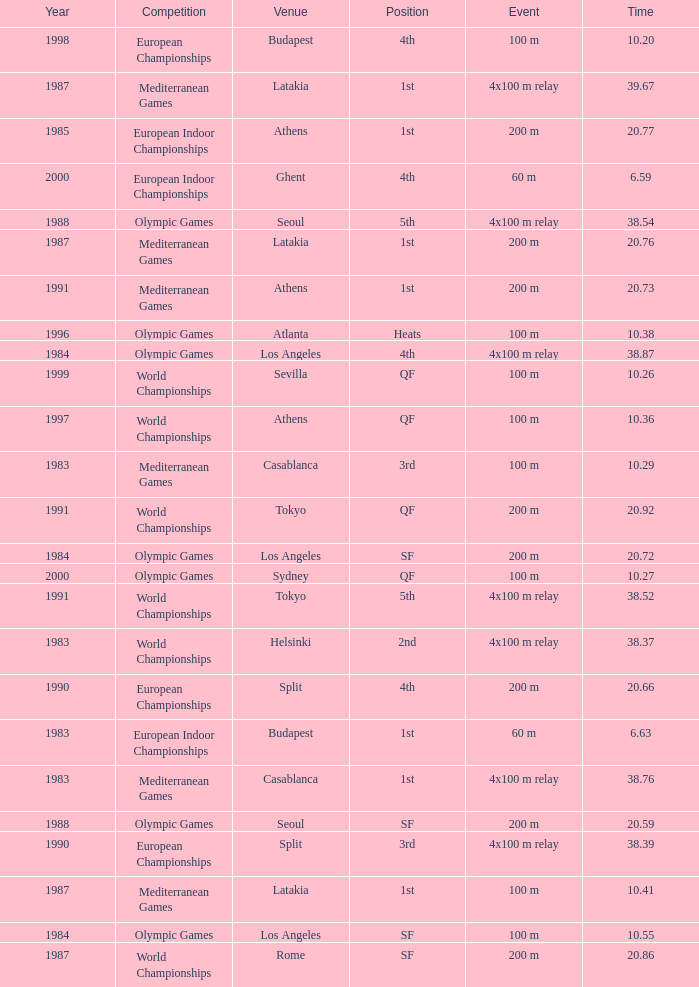What Event has a Position of 1st, a Year of 1983, and a Venue of budapest? 60 m. Could you help me parse every detail presented in this table? {'header': ['Year', 'Competition', 'Venue', 'Position', 'Event', 'Time'], 'rows': [['1998', 'European Championships', 'Budapest', '4th', '100 m', '10.20'], ['1987', 'Mediterranean Games', 'Latakia', '1st', '4x100 m relay', '39.67'], ['1985', 'European Indoor Championships', 'Athens', '1st', '200 m', '20.77'], ['2000', 'European Indoor Championships', 'Ghent', '4th', '60 m', '6.59'], ['1988', 'Olympic Games', 'Seoul', '5th', '4x100 m relay', '38.54'], ['1987', 'Mediterranean Games', 'Latakia', '1st', '200 m', '20.76'], ['1991', 'Mediterranean Games', 'Athens', '1st', '200 m', '20.73'], ['1996', 'Olympic Games', 'Atlanta', 'Heats', '100 m', '10.38'], ['1984', 'Olympic Games', 'Los Angeles', '4th', '4x100 m relay', '38.87'], ['1999', 'World Championships', 'Sevilla', 'QF', '100 m', '10.26'], ['1997', 'World Championships', 'Athens', 'QF', '100 m', '10.36'], ['1983', 'Mediterranean Games', 'Casablanca', '3rd', '100 m', '10.29'], ['1991', 'World Championships', 'Tokyo', 'QF', '200 m', '20.92'], ['1984', 'Olympic Games', 'Los Angeles', 'SF', '200 m', '20.72'], ['2000', 'Olympic Games', 'Sydney', 'QF', '100 m', '10.27'], ['1991', 'World Championships', 'Tokyo', '5th', '4x100 m relay', '38.52'], ['1983', 'World Championships', 'Helsinki', '2nd', '4x100 m relay', '38.37'], ['1990', 'European Championships', 'Split', '4th', '200 m', '20.66'], ['1983', 'European Indoor Championships', 'Budapest', '1st', '60 m', '6.63'], ['1983', 'Mediterranean Games', 'Casablanca', '1st', '4x100 m relay', '38.76'], ['1988', 'Olympic Games', 'Seoul', 'SF', '200 m', '20.59'], ['1990', 'European Championships', 'Split', '3rd', '4x100 m relay', '38.39'], ['1987', 'Mediterranean Games', 'Latakia', '1st', '100 m', '10.41'], ['1984', 'Olympic Games', 'Los Angeles', 'SF', '100 m', '10.55'], ['1987', 'World Championships', 'Rome', 'SF', '200 m', '20.86']]} 